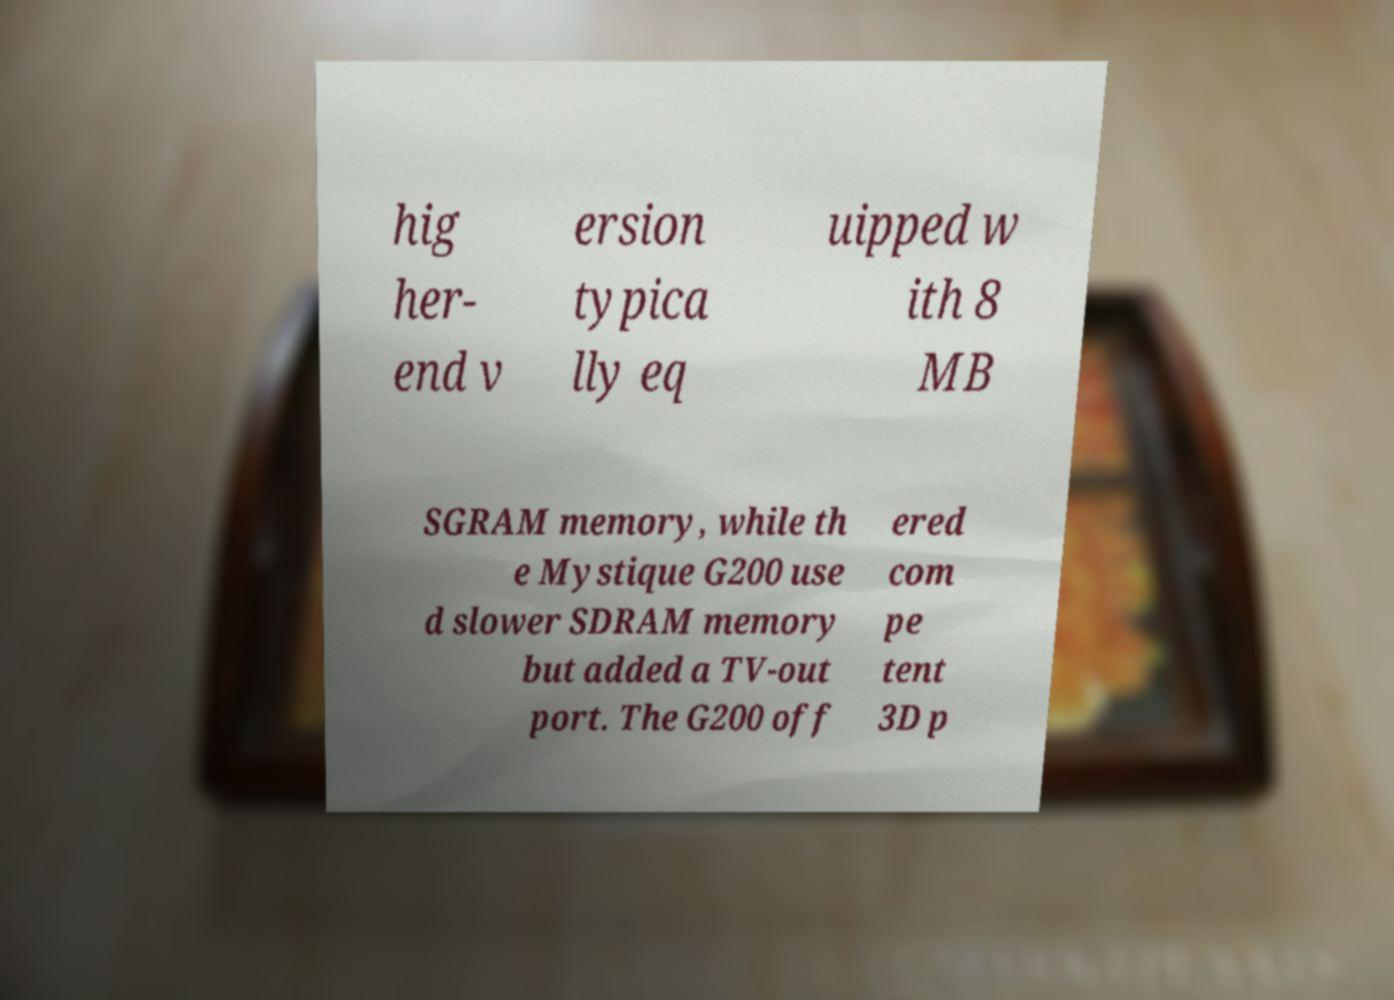Please read and relay the text visible in this image. What does it say? hig her- end v ersion typica lly eq uipped w ith 8 MB SGRAM memory, while th e Mystique G200 use d slower SDRAM memory but added a TV-out port. The G200 off ered com pe tent 3D p 